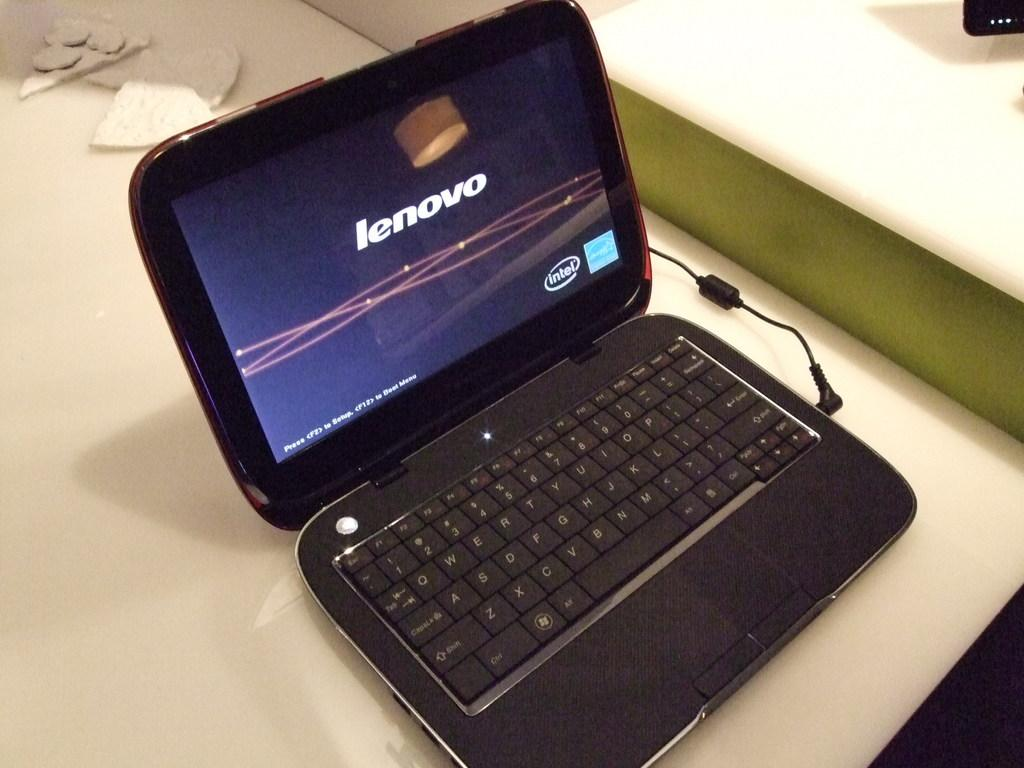What is located in the foreground of the image? There is a table in the foreground of the image. What is placed on the table? There is a laptop on the table. What else can be seen on the table? There is a cable on the table. What is visible at the top of the image? There are objects visible at the top of the image. Can you see a kitty playing with a cow in the image? There is no kitty or cow present in the image. What type of tank is visible in the image? There is no tank present in the image. 